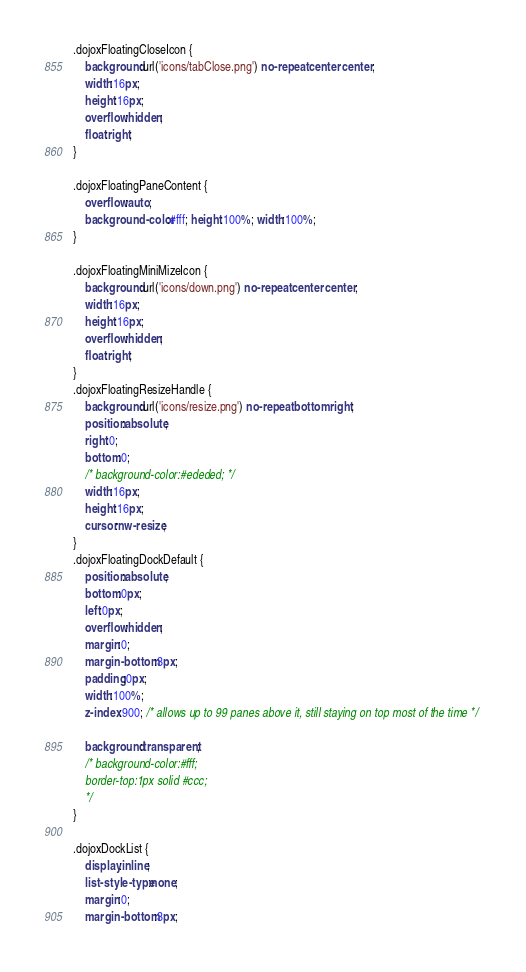Convert code to text. <code><loc_0><loc_0><loc_500><loc_500><_CSS_>.dojoxFloatingCloseIcon {
	background:url('icons/tabClose.png') no-repeat center center; 
	width:16px;
	height:16px; 
	overflow:hidden;
	float:right; 
}

.dojoxFloatingPaneContent {
	overflow:auto; 
	background-color:#fff; height:100%; width:100%; 
}

.dojoxFloatingMiniMizeIcon {
	background:url('icons/down.png') no-repeat center center; 
	width:16px;
	height:16px; 
	overflow:hidden;
	float:right; 
}
.dojoxFloatingResizeHandle {
	background:url('icons/resize.png') no-repeat bottom right;
	position:absolute; 
	right:0; 
	bottom:0; 	
	/* background-color:#ededed; */
	width:16px;
	height:16px; 
	cursor:nw-resize;
}
.dojoxFloatingDockDefault {
	position:absolute;
	bottom:0px;
	left:0px;
	overflow:hidden; 
	margin:0;
	margin-bottom:3px; 
	padding:0px; 
	width:100%;
	z-index:900; /* allows up to 99 panes above it, still staying on top most of the time */ 

	background:transparent;
	/* background-color:#fff; 
	border-top:1px solid #ccc; 
	*/
}

.dojoxDockList { 
	display:inline; 
	list-style-type:none; 
	margin:0; 
	margin-bottom:3px; </code> 